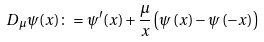Convert formula to latex. <formula><loc_0><loc_0><loc_500><loc_500>D _ { \mu } \psi ( x ) \colon = \psi ^ { \prime } ( x ) + \frac { \mu } { x } \left ( \psi \left ( x \right ) - \psi \left ( - x \right ) \right )</formula> 